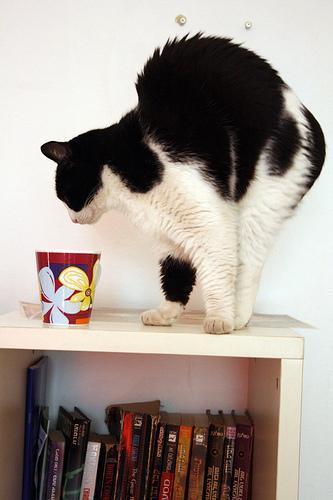How many of the cat's feet are showing?
Give a very brief answer. 3. How many books can you see?
Give a very brief answer. 1. 